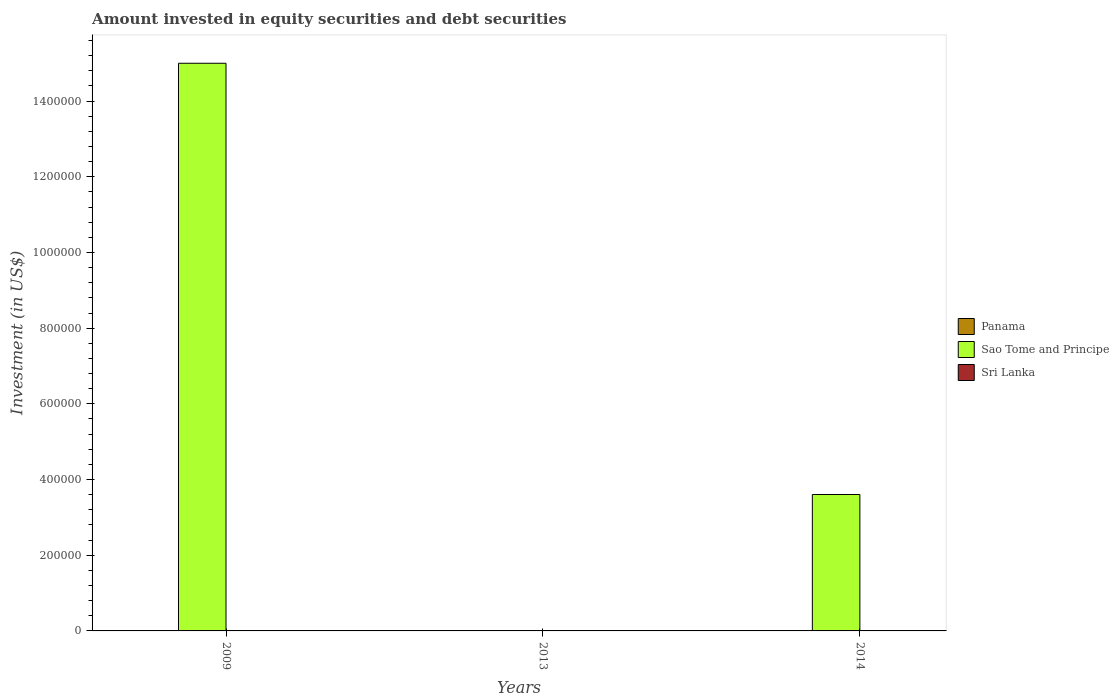How many different coloured bars are there?
Keep it short and to the point. 1. Are the number of bars on each tick of the X-axis equal?
Offer a very short reply. No. What is the label of the 1st group of bars from the left?
Offer a terse response. 2009. In how many cases, is the number of bars for a given year not equal to the number of legend labels?
Provide a short and direct response. 3. Across all years, what is the maximum amount invested in equity securities and debt securities in Sao Tome and Principe?
Provide a succinct answer. 1.50e+06. In which year was the amount invested in equity securities and debt securities in Sao Tome and Principe maximum?
Keep it short and to the point. 2009. What is the difference between the amount invested in equity securities and debt securities in Sao Tome and Principe in 2009 and that in 2014?
Provide a short and direct response. 1.14e+06. What is the difference between the amount invested in equity securities and debt securities in Sri Lanka in 2014 and the amount invested in equity securities and debt securities in Sao Tome and Principe in 2009?
Keep it short and to the point. -1.50e+06. In how many years, is the amount invested in equity securities and debt securities in Panama greater than 920000 US$?
Ensure brevity in your answer.  0. What is the ratio of the amount invested in equity securities and debt securities in Sao Tome and Principe in 2009 to that in 2014?
Your answer should be very brief. 4.16. What is the difference between the highest and the lowest amount invested in equity securities and debt securities in Sao Tome and Principe?
Offer a very short reply. 1.50e+06. Is it the case that in every year, the sum of the amount invested in equity securities and debt securities in Sri Lanka and amount invested in equity securities and debt securities in Panama is greater than the amount invested in equity securities and debt securities in Sao Tome and Principe?
Make the answer very short. No. How many years are there in the graph?
Provide a short and direct response. 3. Where does the legend appear in the graph?
Offer a terse response. Center right. What is the title of the graph?
Offer a terse response. Amount invested in equity securities and debt securities. Does "Kazakhstan" appear as one of the legend labels in the graph?
Your response must be concise. No. What is the label or title of the Y-axis?
Ensure brevity in your answer.  Investment (in US$). What is the Investment (in US$) in Panama in 2009?
Your response must be concise. 0. What is the Investment (in US$) in Sao Tome and Principe in 2009?
Make the answer very short. 1.50e+06. What is the Investment (in US$) in Sao Tome and Principe in 2013?
Keep it short and to the point. 0. What is the Investment (in US$) of Panama in 2014?
Ensure brevity in your answer.  0. What is the Investment (in US$) in Sao Tome and Principe in 2014?
Your answer should be very brief. 3.60e+05. Across all years, what is the maximum Investment (in US$) of Sao Tome and Principe?
Provide a succinct answer. 1.50e+06. What is the total Investment (in US$) in Sao Tome and Principe in the graph?
Give a very brief answer. 1.86e+06. What is the total Investment (in US$) of Sri Lanka in the graph?
Keep it short and to the point. 0. What is the difference between the Investment (in US$) of Sao Tome and Principe in 2009 and that in 2014?
Offer a terse response. 1.14e+06. What is the average Investment (in US$) of Sao Tome and Principe per year?
Provide a succinct answer. 6.20e+05. What is the average Investment (in US$) of Sri Lanka per year?
Offer a terse response. 0. What is the ratio of the Investment (in US$) in Sao Tome and Principe in 2009 to that in 2014?
Offer a terse response. 4.16. What is the difference between the highest and the lowest Investment (in US$) of Sao Tome and Principe?
Keep it short and to the point. 1.50e+06. 